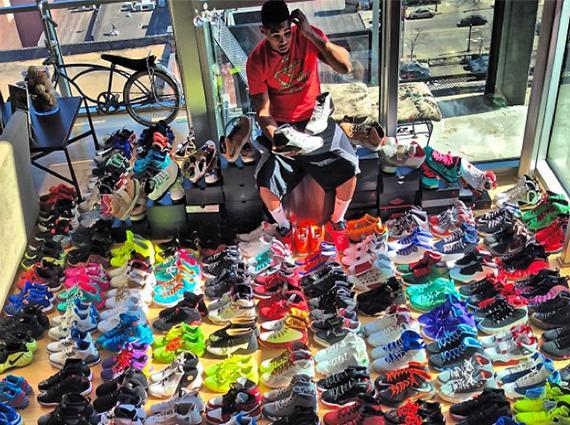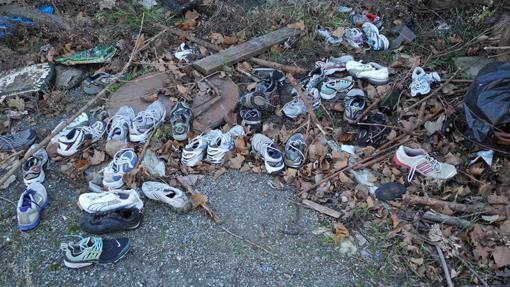The first image is the image on the left, the second image is the image on the right. Assess this claim about the two images: "An image shows two horizontal rows of shoes sitting on the grass.". Correct or not? Answer yes or no. No. 